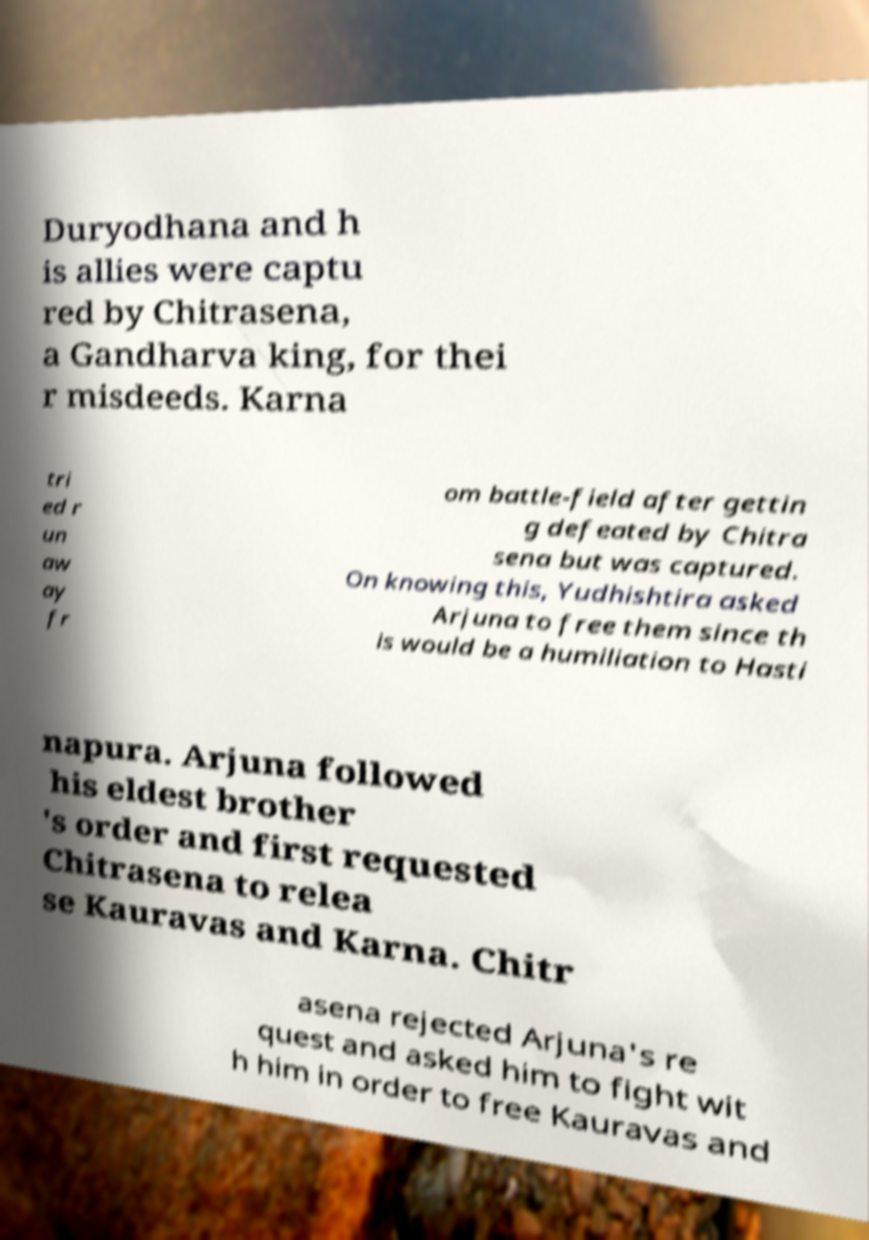Could you extract and type out the text from this image? Duryodhana and h is allies were captu red by Chitrasena, a Gandharva king, for thei r misdeeds. Karna tri ed r un aw ay fr om battle-field after gettin g defeated by Chitra sena but was captured. On knowing this, Yudhishtira asked Arjuna to free them since th is would be a humiliation to Hasti napura. Arjuna followed his eldest brother 's order and first requested Chitrasena to relea se Kauravas and Karna. Chitr asena rejected Arjuna's re quest and asked him to fight wit h him in order to free Kauravas and 